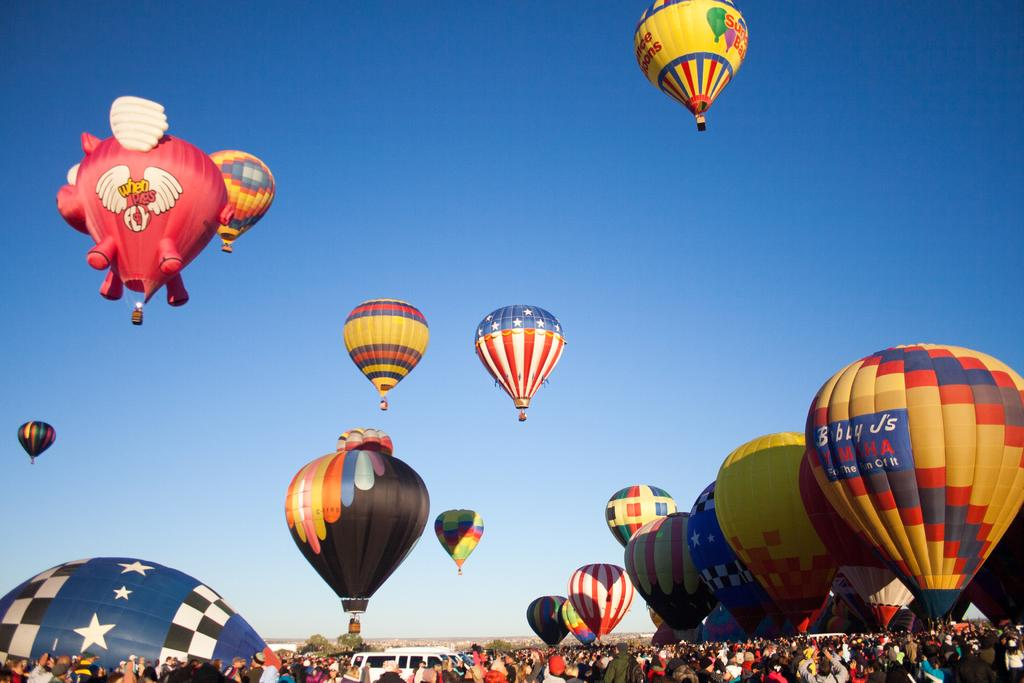<image>
Create a compact narrative representing the image presented. A sky full of hot air ballons and one says When Pigs Fly. 